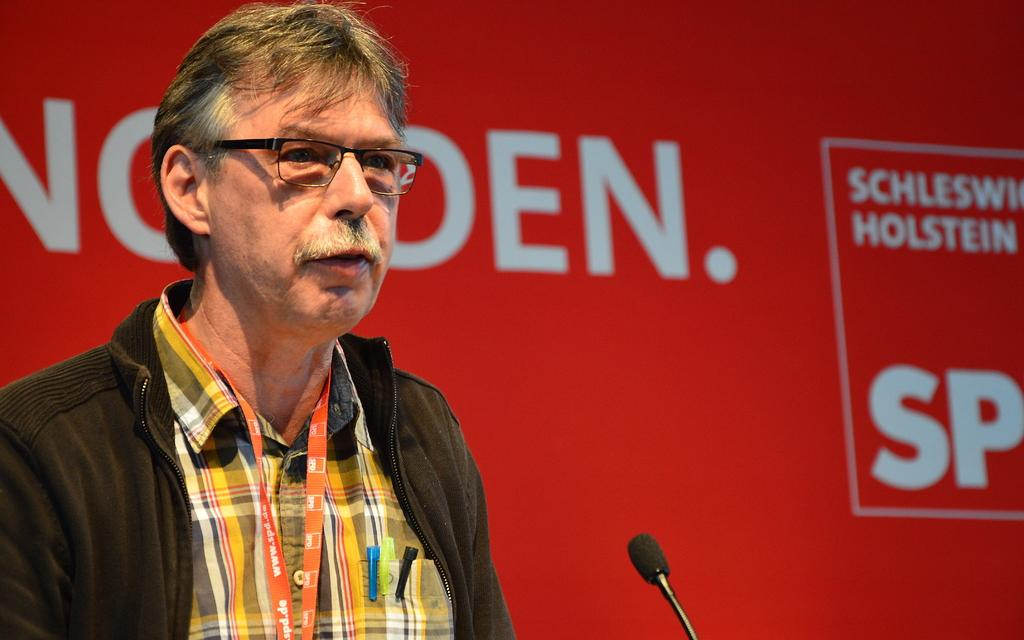Who is the main subject in the image? There is a man in the image. What is the man doing in the image? The man is standing and speaking with the help of a microphone. What can be seen in the background of the image? There is a board with text in the background. What is the man wearing around his neck? The man is wearing a tag around his neck. What type of wood is being used to play with the balls in the image? There is no wood or balls present in the image; it features a man standing and speaking with a microphone. 